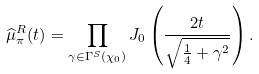<formula> <loc_0><loc_0><loc_500><loc_500>\widehat { \mu } _ { \pi } ^ { R } ( t ) = \prod _ { \gamma \in \Gamma ^ { S } ( \chi _ { 0 } ) } J _ { 0 } \left ( \frac { 2 t } { \sqrt { \frac { 1 } { 4 } + \gamma ^ { 2 } } } \right ) .</formula> 